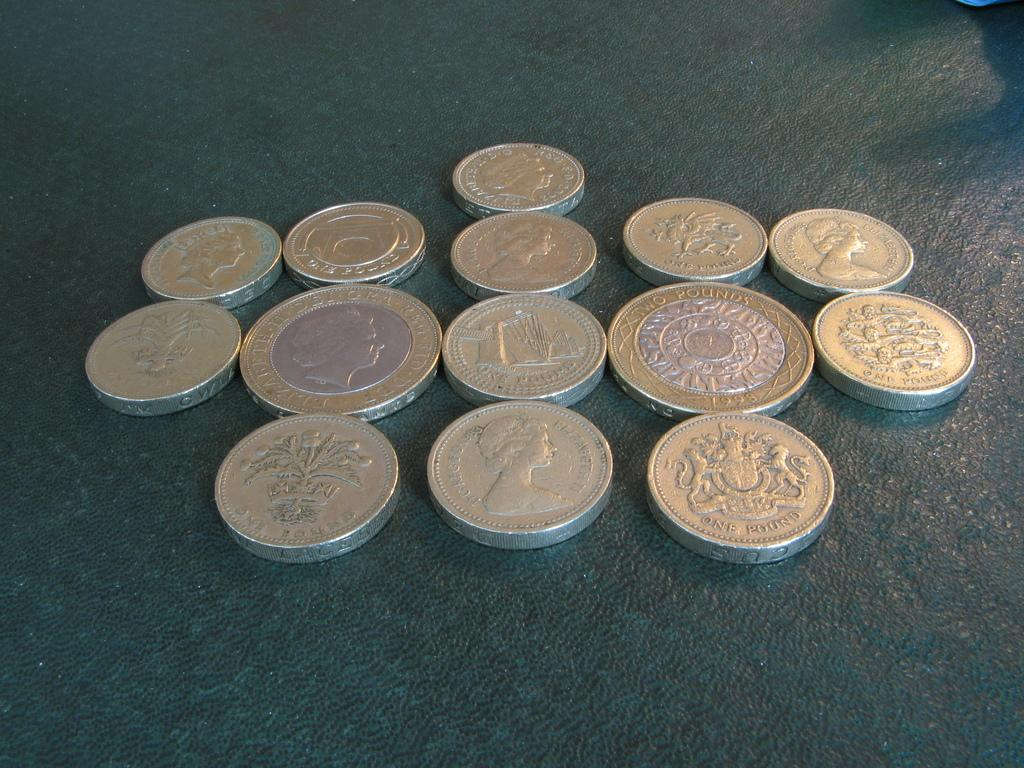<image>
Offer a succinct explanation of the picture presented. Various British One and Two Pound coins with the Queens head. 